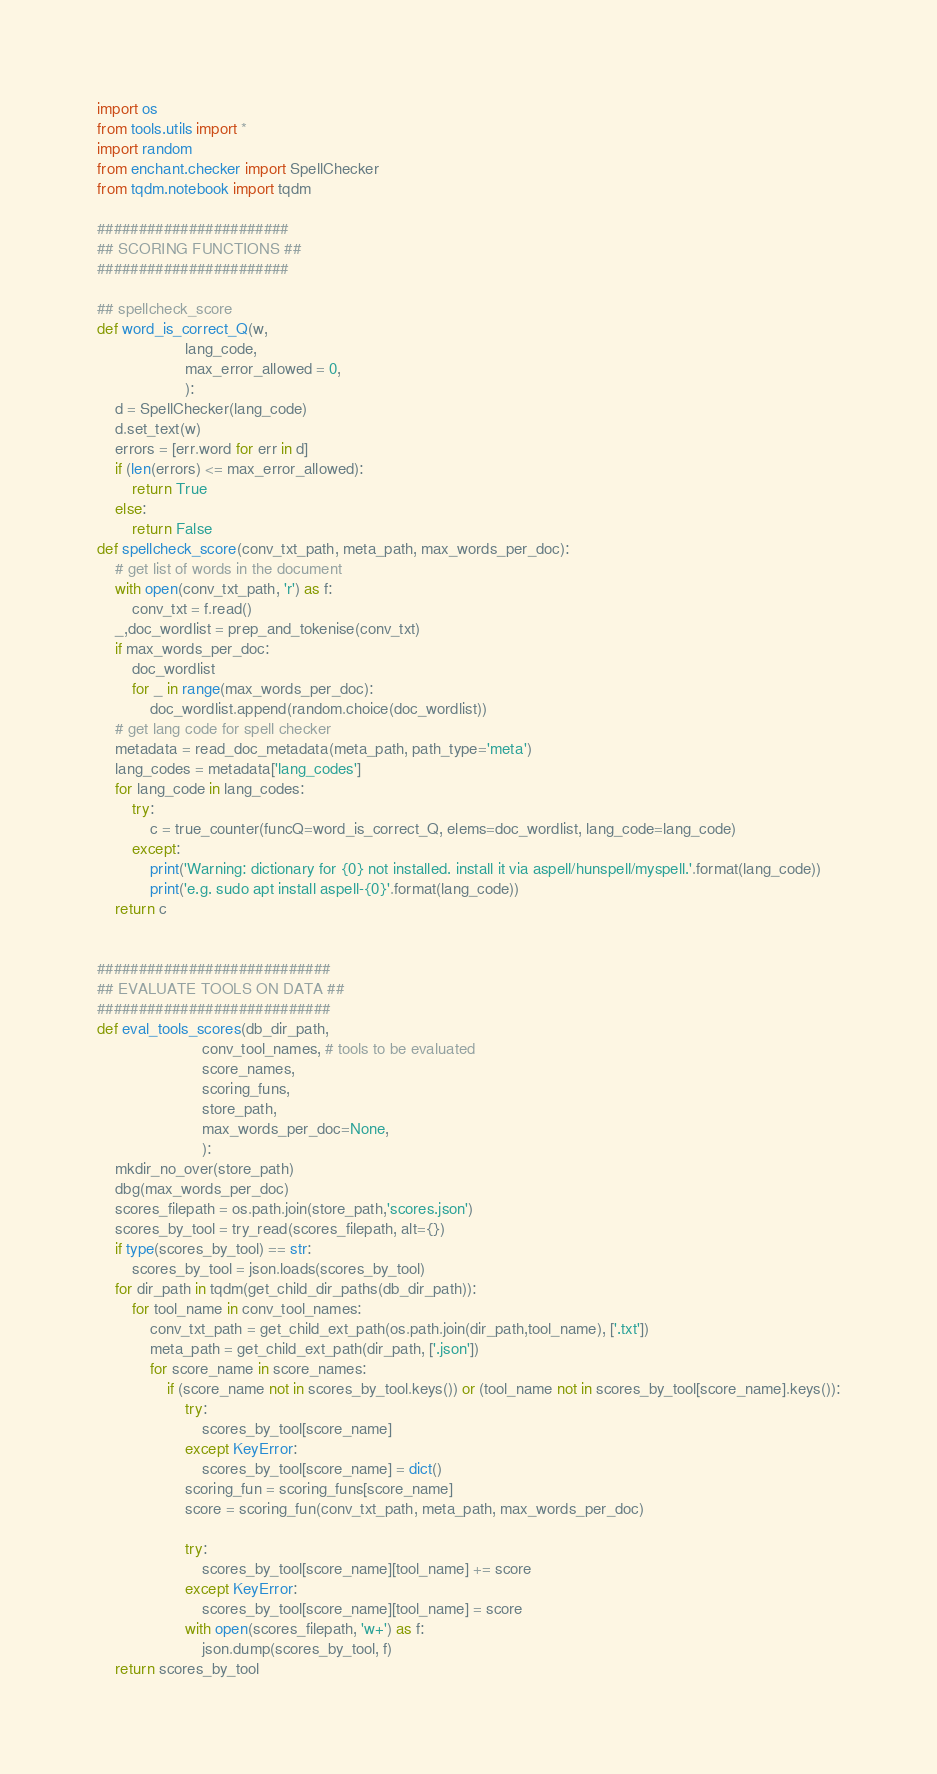<code> <loc_0><loc_0><loc_500><loc_500><_Python_>import os
from tools.utils import *
import random
from enchant.checker import SpellChecker
from tqdm.notebook import tqdm

#######################
## SCORING FUNCTIONS ##
#######################

## spellcheck_score
def word_is_correct_Q(w,
                    lang_code,
                    max_error_allowed = 0,
                    ):
    d = SpellChecker(lang_code)
    d.set_text(w)
    errors = [err.word for err in d]
    if (len(errors) <= max_error_allowed):
        return True
    else:
        return False
def spellcheck_score(conv_txt_path, meta_path, max_words_per_doc):
    # get list of words in the document
    with open(conv_txt_path, 'r') as f:
        conv_txt = f.read()
    _,doc_wordlist = prep_and_tokenise(conv_txt)
    if max_words_per_doc:
        doc_wordlist
        for _ in range(max_words_per_doc):
            doc_wordlist.append(random.choice(doc_wordlist))
    # get lang code for spell checker
    metadata = read_doc_metadata(meta_path, path_type='meta')
    lang_codes = metadata['lang_codes']
    for lang_code in lang_codes:
        try:
            c = true_counter(funcQ=word_is_correct_Q, elems=doc_wordlist, lang_code=lang_code)
        except:
            print('Warning: dictionary for {0} not installed. install it via aspell/hunspell/myspell.'.format(lang_code))
            print('e.g. sudo apt install aspell-{0}'.format(lang_code))
    return c

     
############################
## EVALUATE TOOLS ON DATA ##
############################
def eval_tools_scores(db_dir_path,
                        conv_tool_names, # tools to be evaluated
                        score_names,
                        scoring_funs,
                        store_path,
                        max_words_per_doc=None,
                        ):
    mkdir_no_over(store_path)
    dbg(max_words_per_doc)
    scores_filepath = os.path.join(store_path,'scores.json')
    scores_by_tool = try_read(scores_filepath, alt={})
    if type(scores_by_tool) == str:
        scores_by_tool = json.loads(scores_by_tool)
    for dir_path in tqdm(get_child_dir_paths(db_dir_path)):
        for tool_name in conv_tool_names:
            conv_txt_path = get_child_ext_path(os.path.join(dir_path,tool_name), ['.txt']) 
            meta_path = get_child_ext_path(dir_path, ['.json'])
            for score_name in score_names:
                if (score_name not in scores_by_tool.keys()) or (tool_name not in scores_by_tool[score_name].keys()):
                    try:
                        scores_by_tool[score_name]
                    except KeyError:
                        scores_by_tool[score_name] = dict()
                    scoring_fun = scoring_funs[score_name]
                    score = scoring_fun(conv_txt_path, meta_path, max_words_per_doc)
                    
                    try:
                        scores_by_tool[score_name][tool_name] += score
                    except KeyError:
                        scores_by_tool[score_name][tool_name] = score
                    with open(scores_filepath, 'w+') as f:
                        json.dump(scores_by_tool, f)
    return scores_by_tool

</code> 